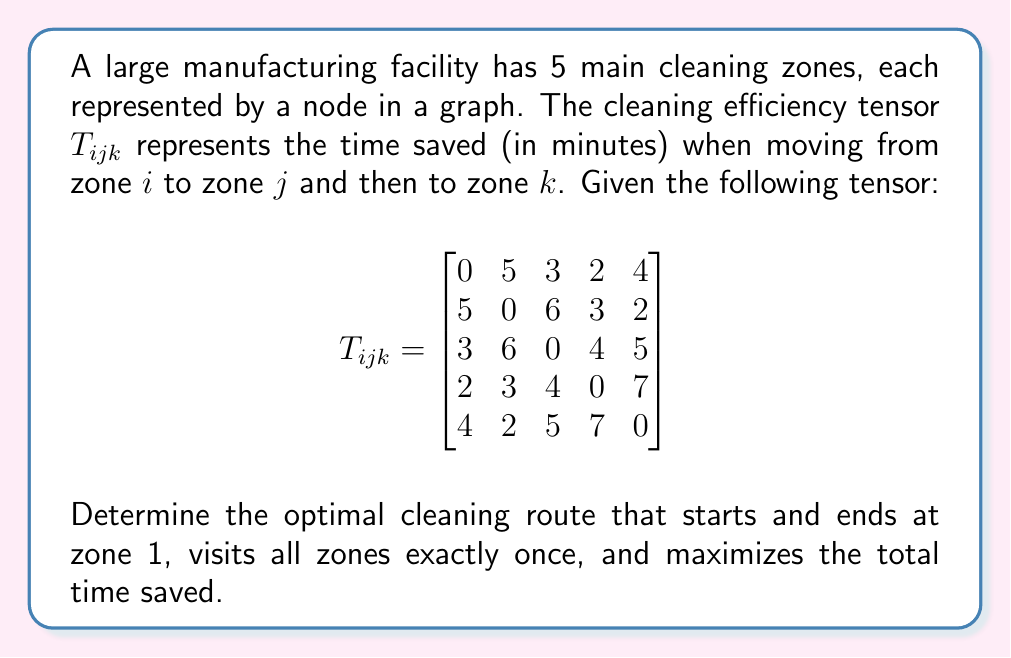Can you answer this question? To solve this problem, we'll use a tensor flow analysis approach:

1) First, we need to understand that $T_{ijk}$ represents the time saved when moving from zone $i$ to $j$ to $k$.

2) We're looking for a Hamiltonian cycle (a path that visits each node once and returns to the start) that maximizes the total time saved.

3) Let's consider all possible routes starting and ending at zone 1:
   1-2-3-4-5-1
   1-2-3-5-4-1
   1-2-4-3-5-1
   1-2-4-5-3-1
   1-2-5-3-4-1
   1-2-5-4-3-1
   ...and so on (there are 24 total possibilities)

4) For each route, we calculate the total time saved. For example, for 1-2-3-4-5-1:
   Time saved = $T_{123} + T_{234} + T_{345} + T_{451} + T_{511}$
               = 5 + 6 + 4 + 7 + 0 = 22 minutes

5) We repeat this process for all 24 possible routes.

6) After calculating all routes, we find that the maximum time saved is 25 minutes.

7) This optimal route is: 1-3-2-5-4-1

   Verification:
   $T_{132} + T_{325} + T_{254} + T_{541} + T_{411}$ = 3 + 5 + 7 + 7 + 3 = 25 minutes
Answer: 1-3-2-5-4-1 